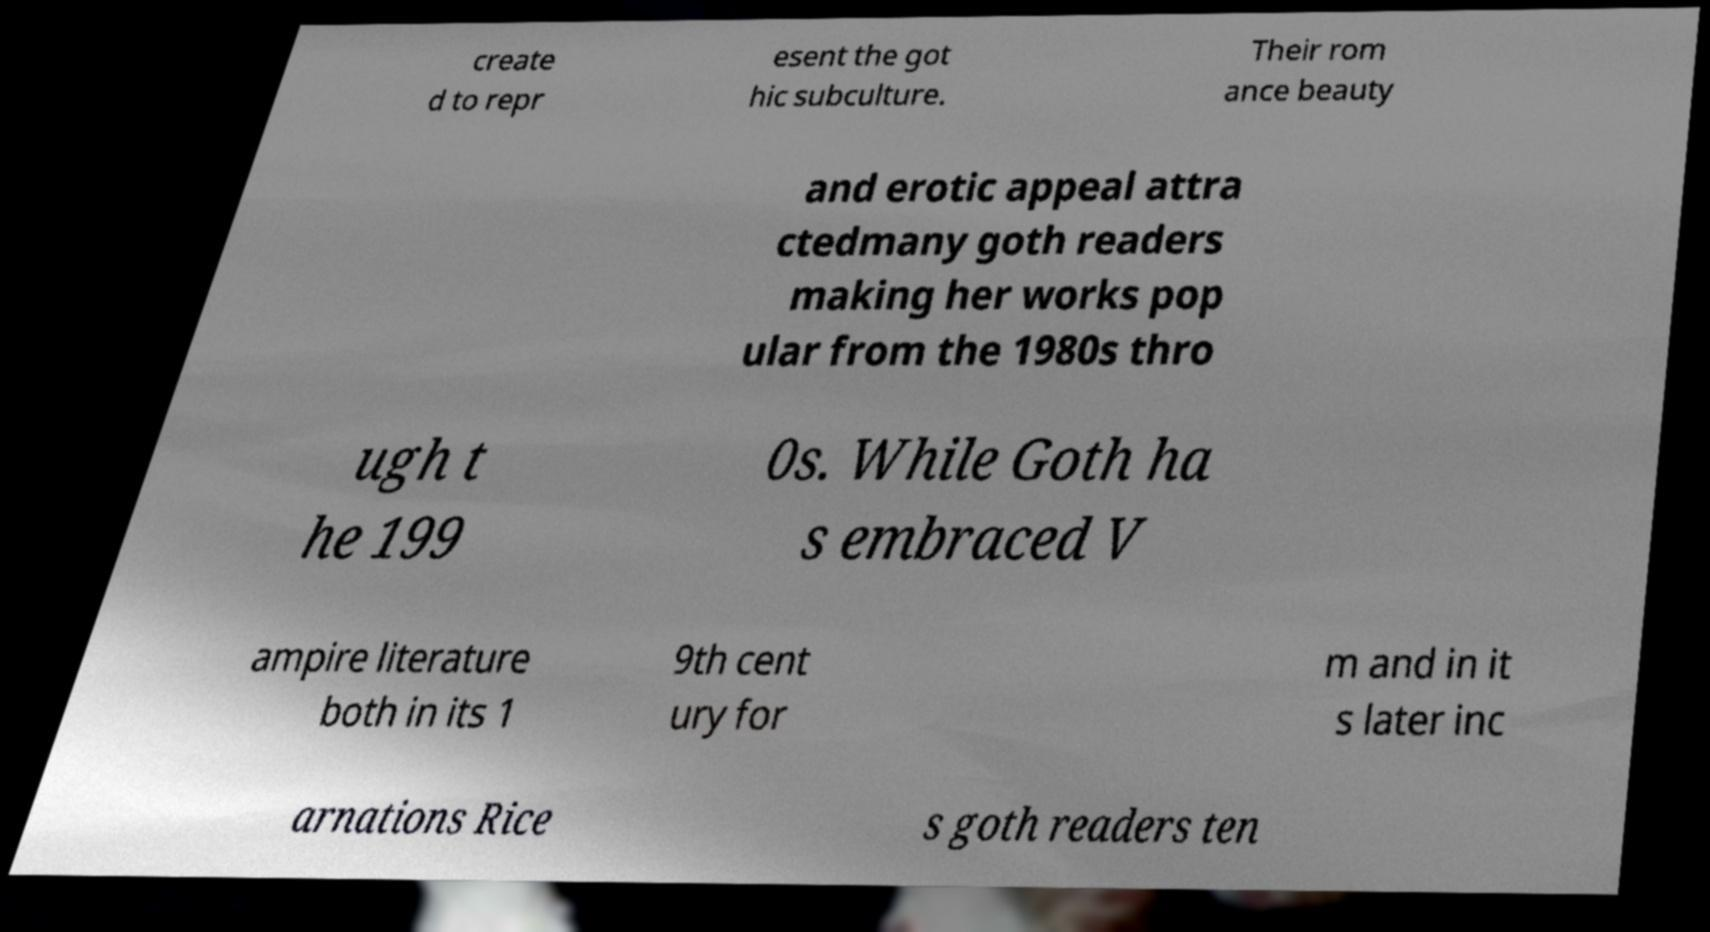Could you extract and type out the text from this image? create d to repr esent the got hic subculture. Their rom ance beauty and erotic appeal attra ctedmany goth readers making her works pop ular from the 1980s thro ugh t he 199 0s. While Goth ha s embraced V ampire literature both in its 1 9th cent ury for m and in it s later inc arnations Rice s goth readers ten 